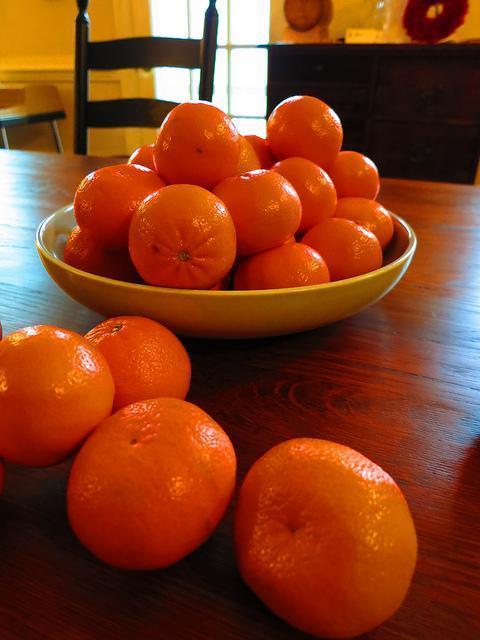How many oranges can be seen?
Give a very brief answer. 10. How many dining tables can be seen?
Give a very brief answer. 1. How many zebras are there altogether?
Give a very brief answer. 0. 